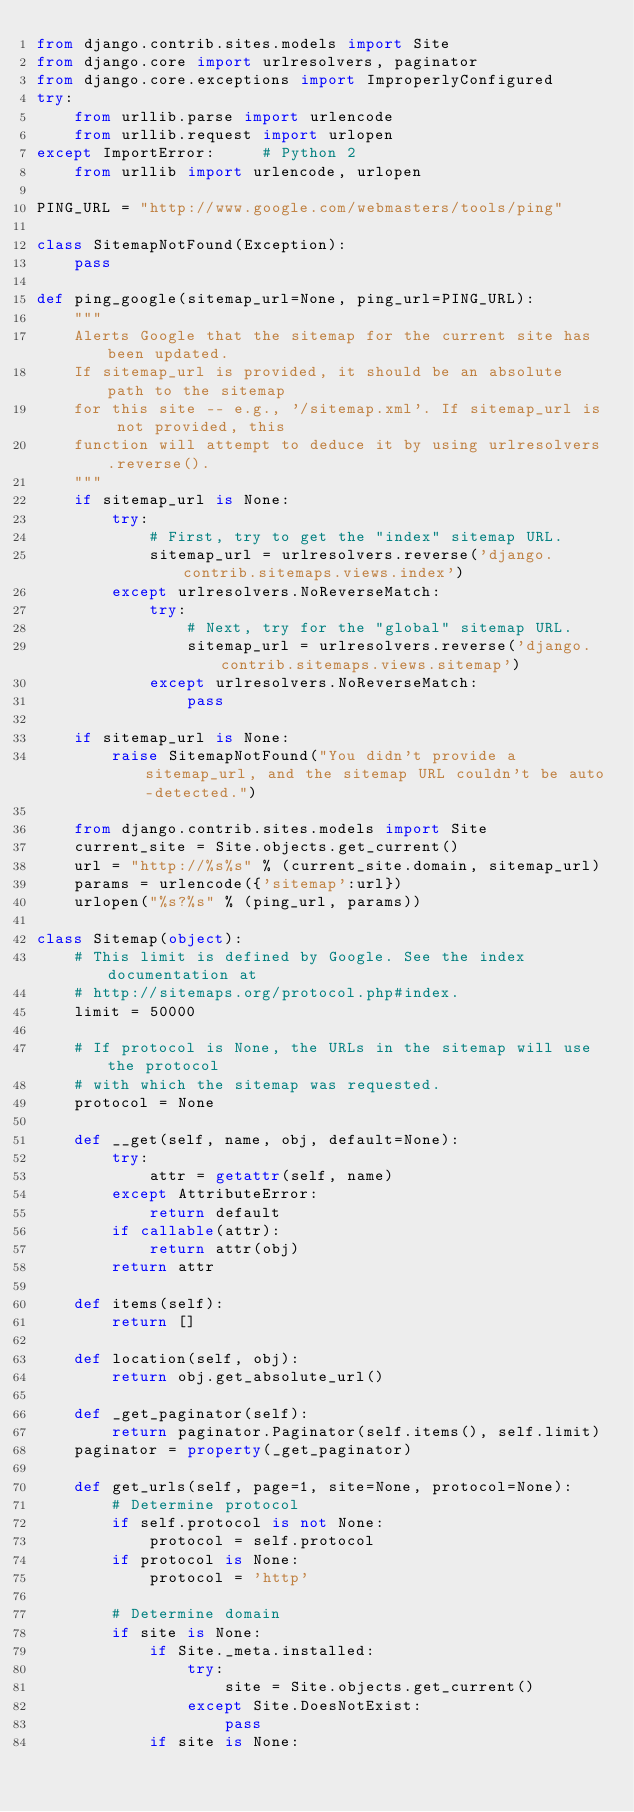<code> <loc_0><loc_0><loc_500><loc_500><_Python_>from django.contrib.sites.models import Site
from django.core import urlresolvers, paginator
from django.core.exceptions import ImproperlyConfigured
try:
    from urllib.parse import urlencode
    from urllib.request import urlopen
except ImportError:     # Python 2
    from urllib import urlencode, urlopen

PING_URL = "http://www.google.com/webmasters/tools/ping"

class SitemapNotFound(Exception):
    pass

def ping_google(sitemap_url=None, ping_url=PING_URL):
    """
    Alerts Google that the sitemap for the current site has been updated.
    If sitemap_url is provided, it should be an absolute path to the sitemap
    for this site -- e.g., '/sitemap.xml'. If sitemap_url is not provided, this
    function will attempt to deduce it by using urlresolvers.reverse().
    """
    if sitemap_url is None:
        try:
            # First, try to get the "index" sitemap URL.
            sitemap_url = urlresolvers.reverse('django.contrib.sitemaps.views.index')
        except urlresolvers.NoReverseMatch:
            try:
                # Next, try for the "global" sitemap URL.
                sitemap_url = urlresolvers.reverse('django.contrib.sitemaps.views.sitemap')
            except urlresolvers.NoReverseMatch:
                pass

    if sitemap_url is None:
        raise SitemapNotFound("You didn't provide a sitemap_url, and the sitemap URL couldn't be auto-detected.")

    from django.contrib.sites.models import Site
    current_site = Site.objects.get_current()
    url = "http://%s%s" % (current_site.domain, sitemap_url)
    params = urlencode({'sitemap':url})
    urlopen("%s?%s" % (ping_url, params))

class Sitemap(object):
    # This limit is defined by Google. See the index documentation at
    # http://sitemaps.org/protocol.php#index.
    limit = 50000

    # If protocol is None, the URLs in the sitemap will use the protocol
    # with which the sitemap was requested.
    protocol = None

    def __get(self, name, obj, default=None):
        try:
            attr = getattr(self, name)
        except AttributeError:
            return default
        if callable(attr):
            return attr(obj)
        return attr

    def items(self):
        return []

    def location(self, obj):
        return obj.get_absolute_url()

    def _get_paginator(self):
        return paginator.Paginator(self.items(), self.limit)
    paginator = property(_get_paginator)

    def get_urls(self, page=1, site=None, protocol=None):
        # Determine protocol
        if self.protocol is not None:
            protocol = self.protocol
        if protocol is None:
            protocol = 'http'

        # Determine domain
        if site is None:
            if Site._meta.installed:
                try:
                    site = Site.objects.get_current()
                except Site.DoesNotExist:
                    pass
            if site is None:</code> 